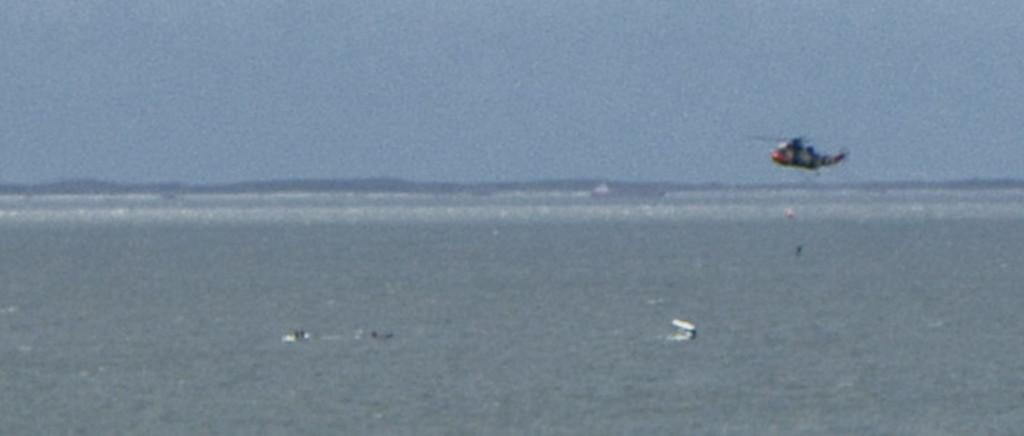What type of aircraft is in the image? There is a rescue helicopter in the image. What is the helicopter doing in the image? The helicopter is flying in the air. What can be seen below the helicopter in the image? There is sea water visible in the image. Are there any people in the water in the image? Yes, there are two men in the water. What is visible in the background of the image? There are mountains visible in the background of the image. What type of insurance policy do the boats in the image have? There are no boats present in the image, so it is not possible to determine any insurance policies. 